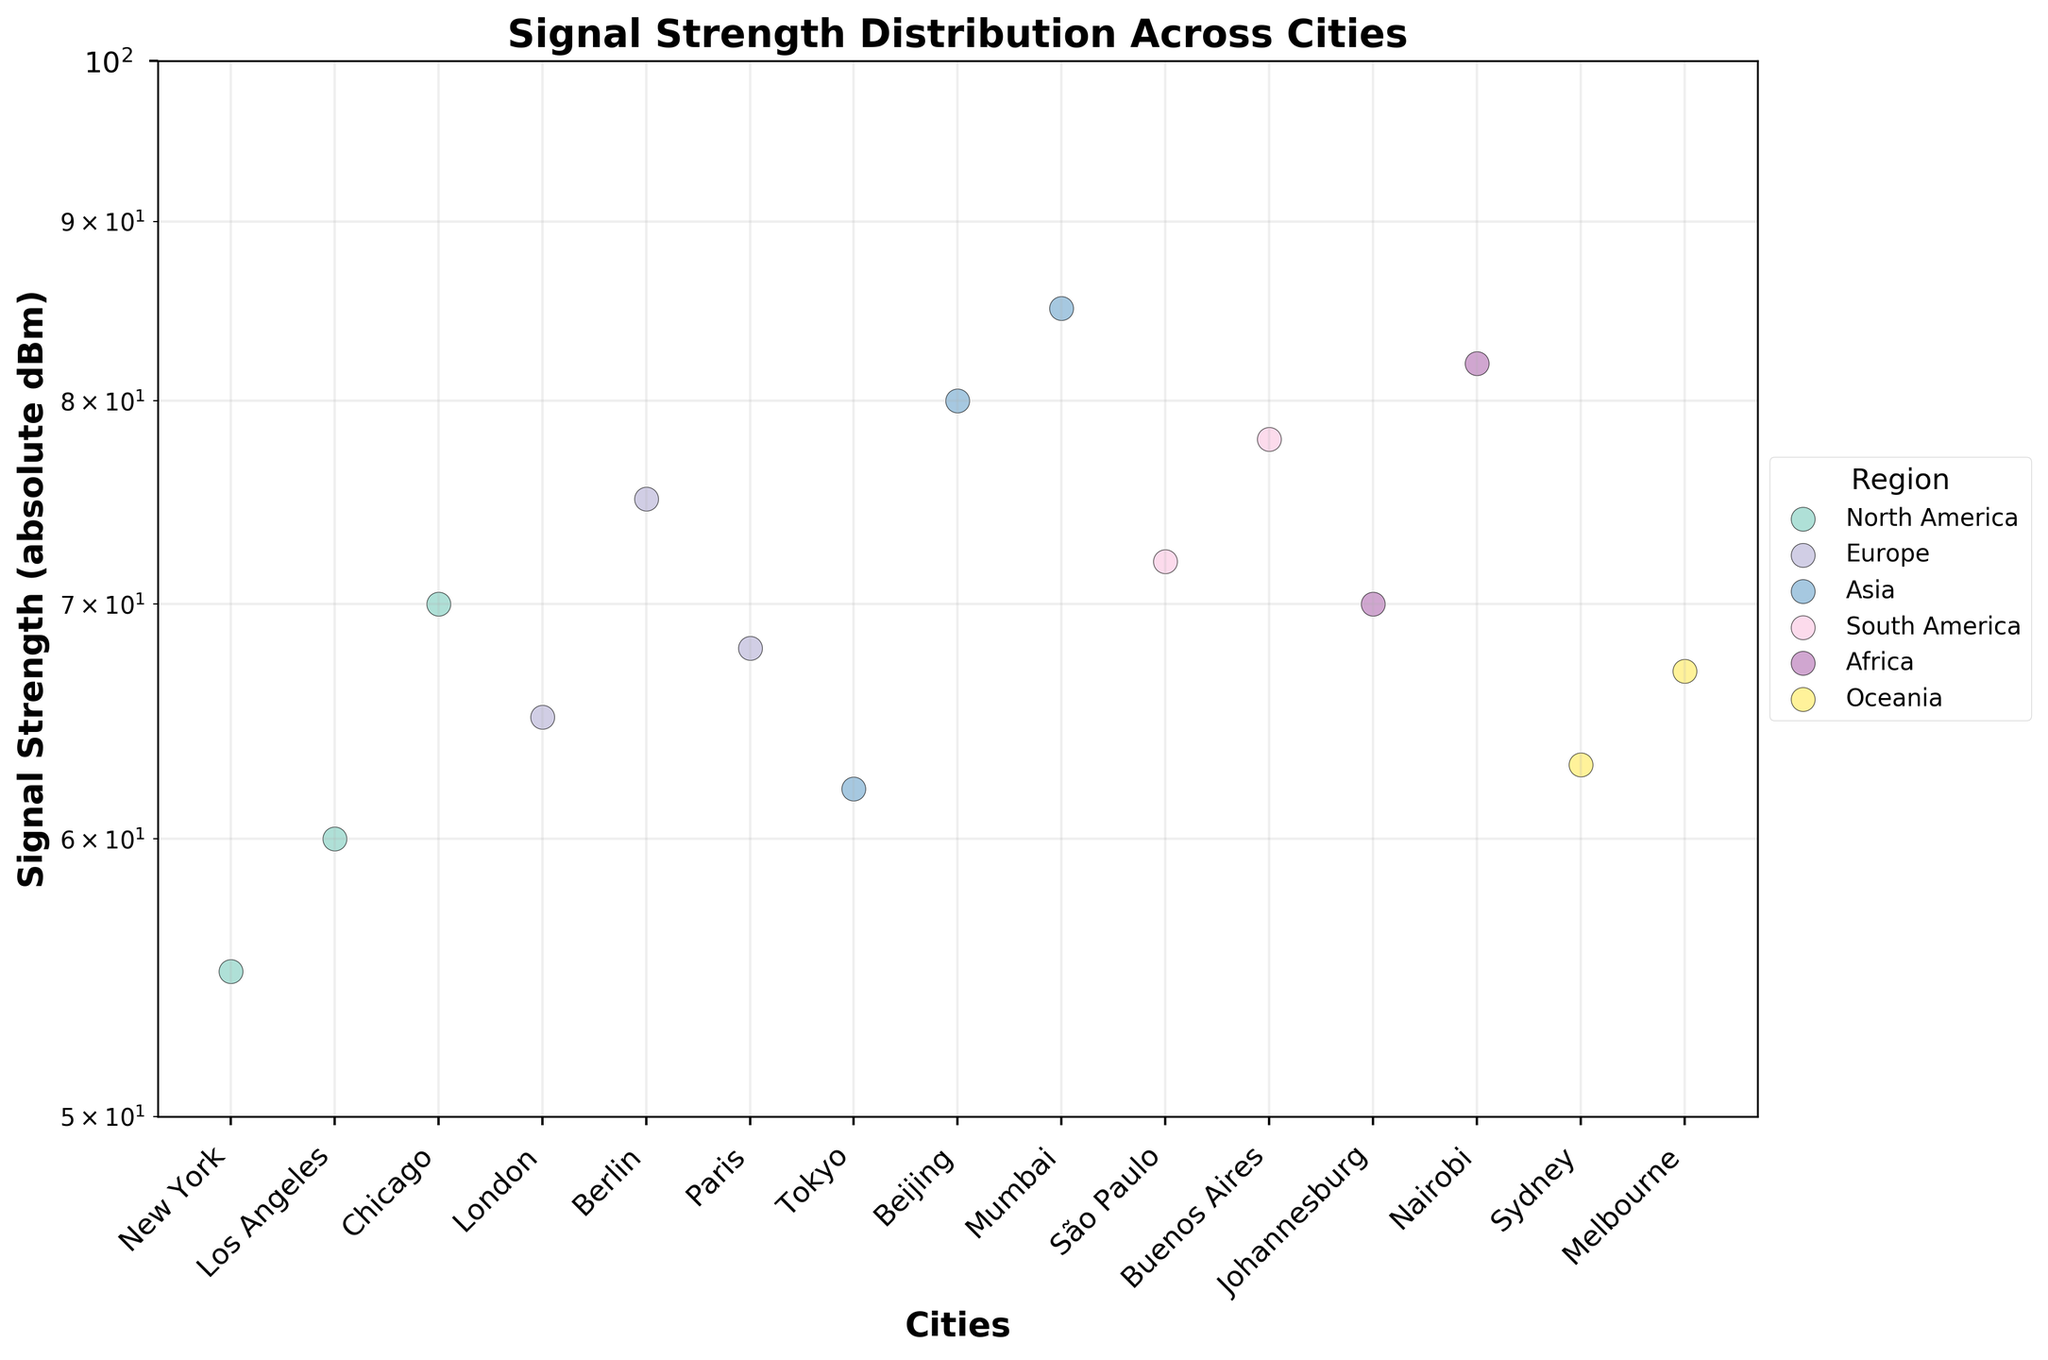What is the title of the plot? The title of the plot is located at the top of the figure in a large, bold font. It reads, 'Signal Strength Distribution Across Cities'.
Answer: Signal Strength Distribution Across Cities Which axis represents the cities? The x-axis, positioned horizontally at the bottom of the plot, represents the cities.
Answer: x-axis What's the range of the y-axis? The y-axis is set to a logarithmic scale and ranges from 50 to 100.
Answer: 50 to 100 Which city in North America has the strongest signal strength? The city in North America with the strongest signal strength would have the smallest absolute value on the y-axis. Referring to the plot, New York has the smallest absolute signal strength at -55 dBm.
Answer: New York What is the signal strength of Tokyo in absolute terms? Signal strength values are shown on the y-axis in absolute dBm. Tokyo's signal strength is plotted at 62 dBm.
Answer: 62 How does the signal strength of São Paulo compare to Buenos Aires? São Paulo has a signal strength of 72 dBm, and Buenos Aires has a signal strength of 78 dBm. Although São Paulo's signal strength is weaker in terms of the dBm value being larger in absolute terms, the value itself is less, indicating a better signal.
Answer: São Paulo's signal is stronger What is the median signal strength in Europe? To determine the median signal strength for Europe, identify the middle value from the sorted list of signal strengths. The European cities have signal strengths of 65 (London), 68 (Paris), and 75 (Berlin). The middle value is 68 (Paris), so the median signal strength is 68 dBm.
Answer: 68 dBm Which region has the city with the weakest signal strength and what is the city's name? The weakest signal strength corresponds to the highest value on the y-axis. The city with the weakest strength is Mumbai in Asia with 85 dBm.
Answer: Mumbai, Asia Which region has the most cities plotted with a signal strength better than 70 dBm? Count the number of cities in each region with a signal strength less than 70 dBm (because a lower absolute dBm value corresponds to better signal strength). North America has 3 cities (New York, Los Angeles, Chicago), Europe has 2 (London, Paris), Asia has 1 (Tokyo), South America has 1 (São Paulo), Africa has 1 (Johannesburg), and Oceania has 2 (Sydney, Melbourne). North America has the most with 3 cities.
Answer: North America Which region appears to have the smallest spread in signal strength values? By visually estimating the range of values along the y-axis for each region on the plot, Oceania appears to have the smallest spread in signal strength values, with Sydney and Melbourne closely positioned around 63 and 67 dBm.
Answer: Oceania 